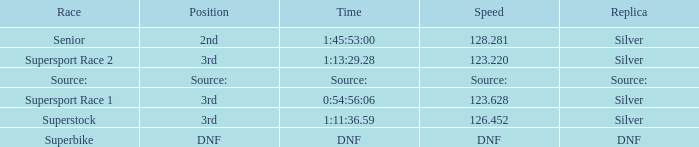Write the full table. {'header': ['Race', 'Position', 'Time', 'Speed', 'Replica'], 'rows': [['Senior', '2nd', '1:45:53:00', '128.281', 'Silver'], ['Supersport Race 2', '3rd', '1:13:29.28', '123.220', 'Silver'], ['Source:', 'Source:', 'Source:', 'Source:', 'Source:'], ['Supersport Race 1', '3rd', '0:54:56:06', '123.628', 'Silver'], ['Superstock', '3rd', '1:11:36.59', '126.452', 'Silver'], ['Superbike', 'DNF', 'DNF', 'DNF', 'DNF']]} Which race has a position of 3rd and a speed of 123.628? Supersport Race 1. 